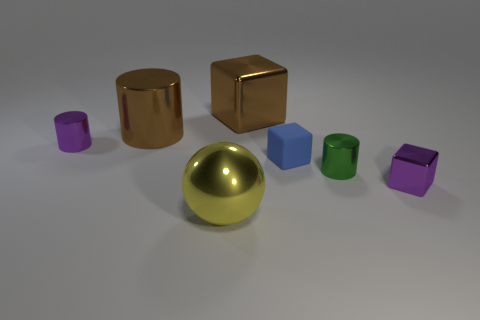Add 3 big yellow rubber balls. How many objects exist? 10 Subtract all cubes. How many objects are left? 4 Subtract all big shiny cubes. Subtract all brown blocks. How many objects are left? 5 Add 4 large brown cubes. How many large brown cubes are left? 5 Add 4 small green metallic blocks. How many small green metallic blocks exist? 4 Subtract 0 cyan cubes. How many objects are left? 7 